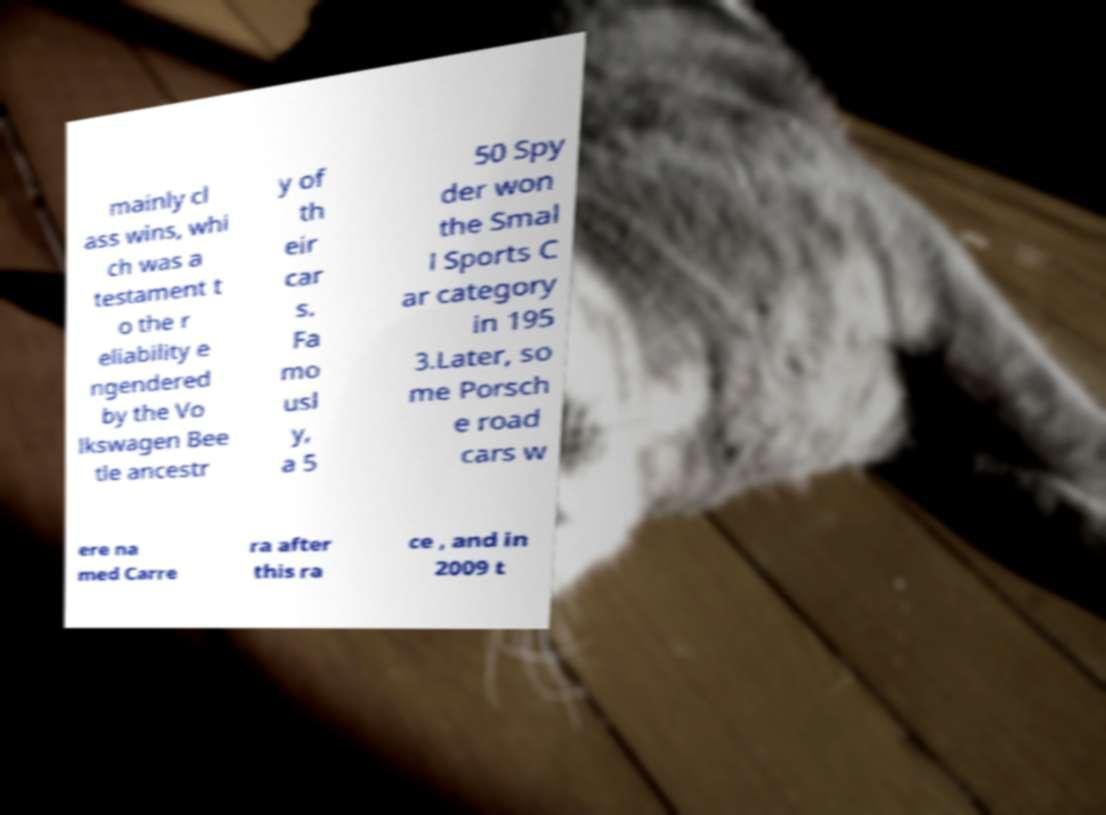Could you assist in decoding the text presented in this image and type it out clearly? mainly cl ass wins, whi ch was a testament t o the r eliability e ngendered by the Vo lkswagen Bee tle ancestr y of th eir car s. Fa mo usl y, a 5 50 Spy der won the Smal l Sports C ar category in 195 3.Later, so me Porsch e road cars w ere na med Carre ra after this ra ce , and in 2009 t 